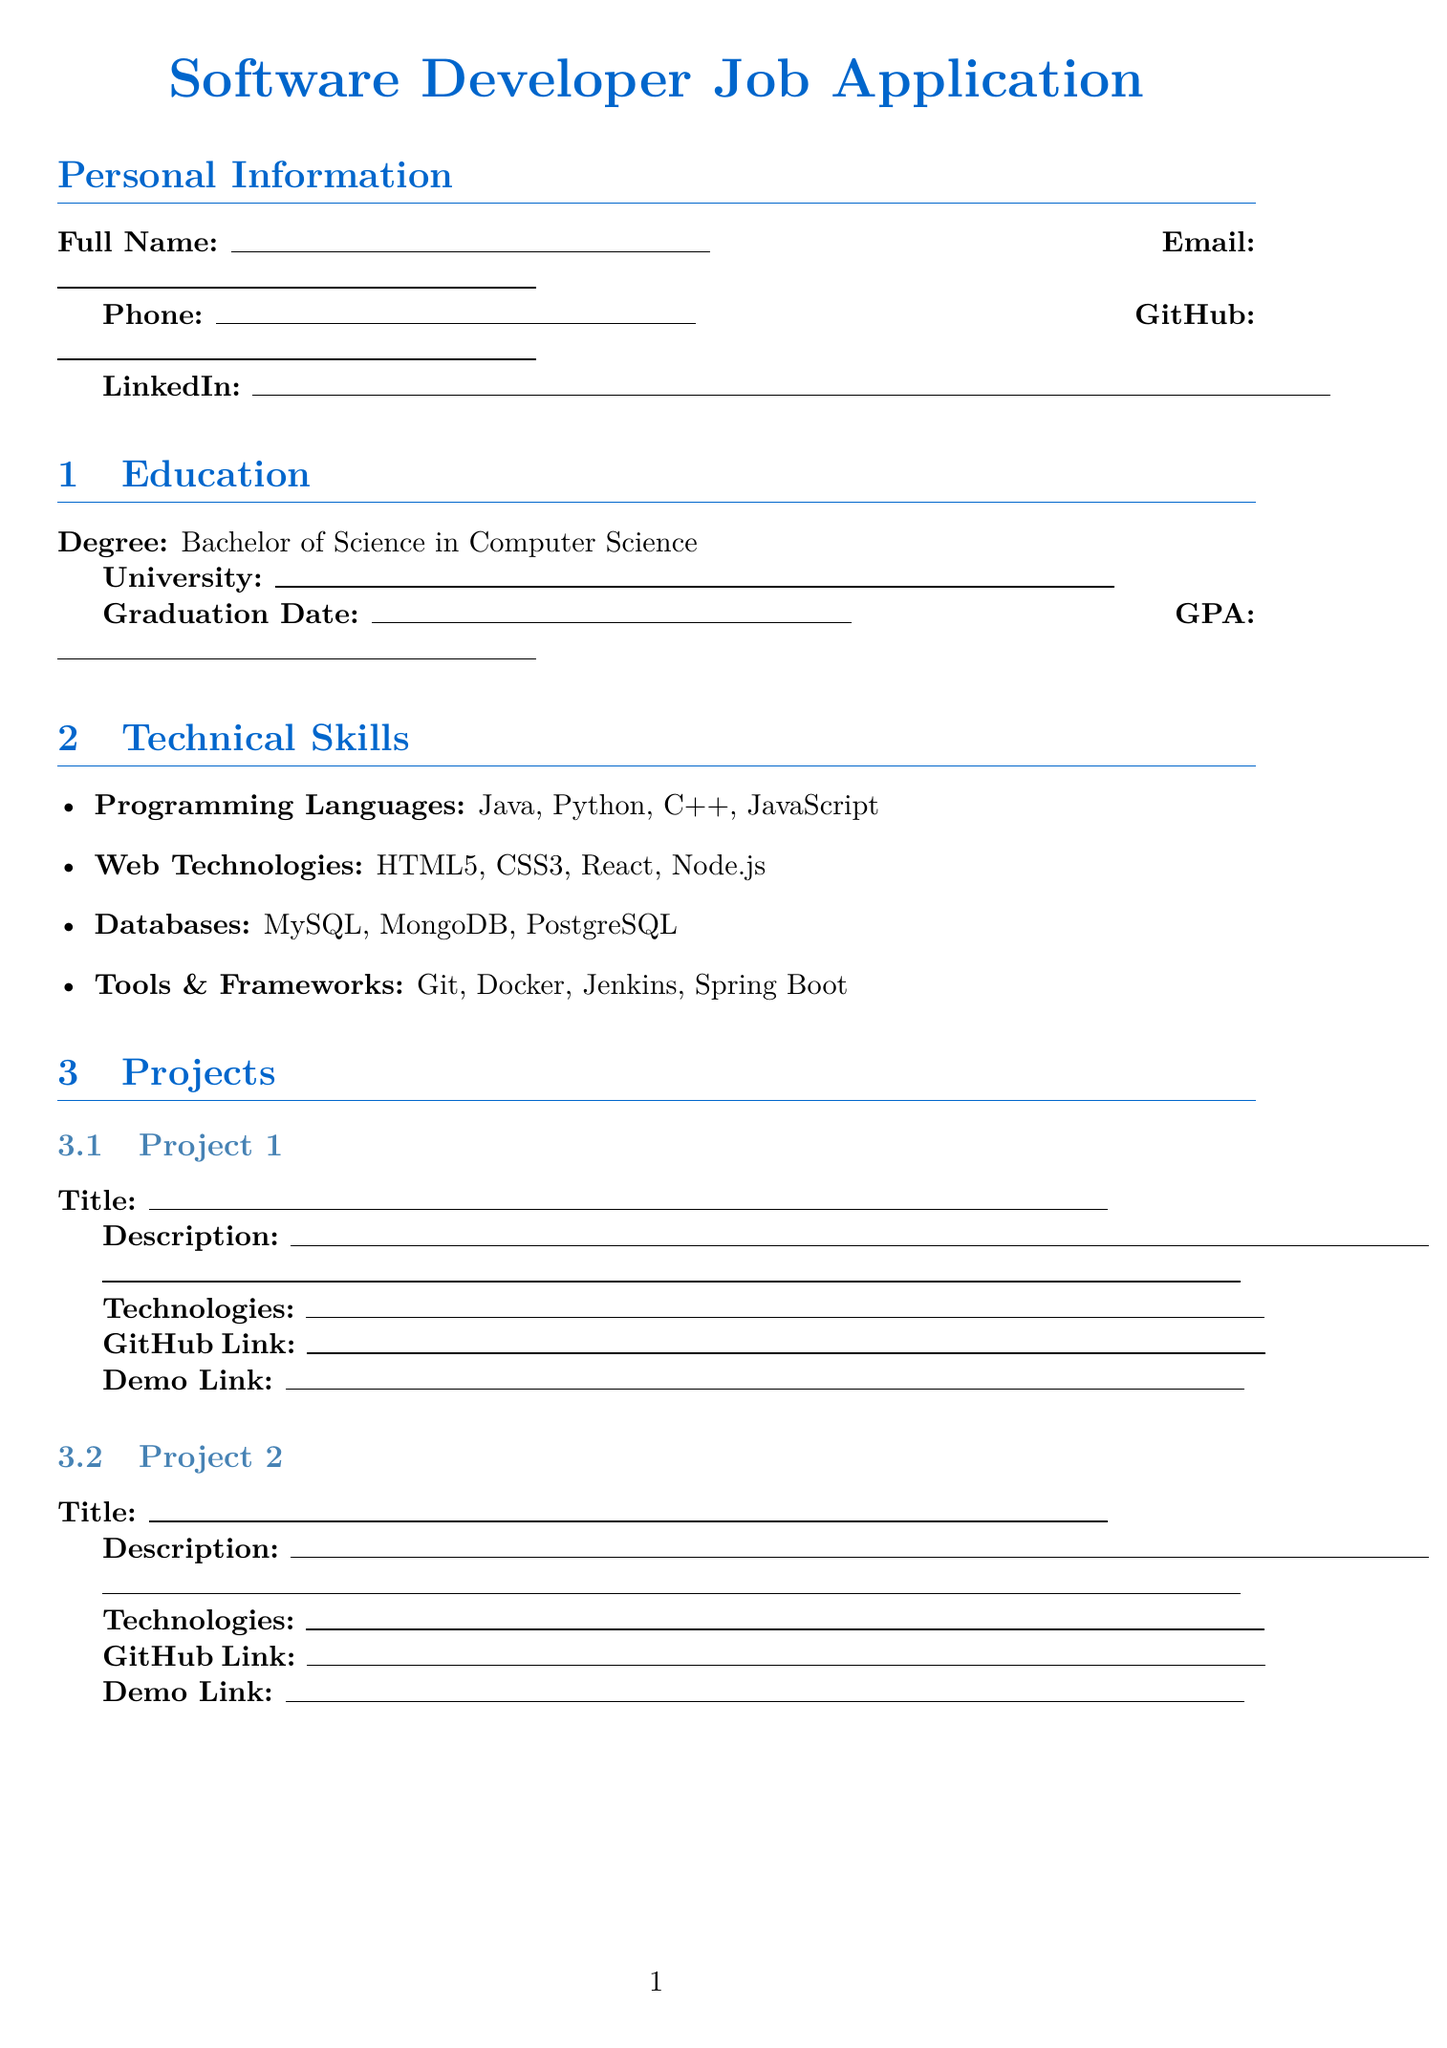What is the degree obtained? The degree obtained is explicitly stated in the education section of the document.
Answer: Bachelor of Science in Computer Science What programming language is listed first? The first programming language in the technical skills section is the first mentioned skill in the list.
Answer: Java What position did the applicant hold during their internship? The position is clearly defined in the experience section of the document.
Answer: Software Development Intern What type of information is included under Additional Information? This section includes details about certifications and hackathons, which are specific types of additional qualifications.
Answer: Certifications and Hackathons How many web technologies are listed? The total number of web technologies in the technical skills section can be counted directly from the skills listed.
Answer: 4 What is the last section of the document? The last section can be identified by its title as evident in the document structure.
Answer: Cover Letter 